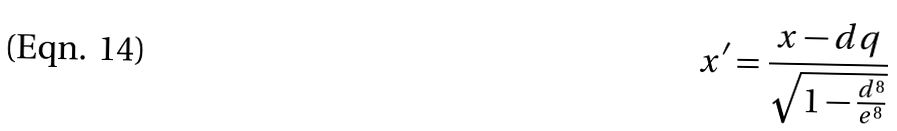<formula> <loc_0><loc_0><loc_500><loc_500>x ^ { \prime } = \frac { x - d q } { \sqrt { 1 - \frac { d ^ { 8 } } { e ^ { 8 } } } }</formula> 